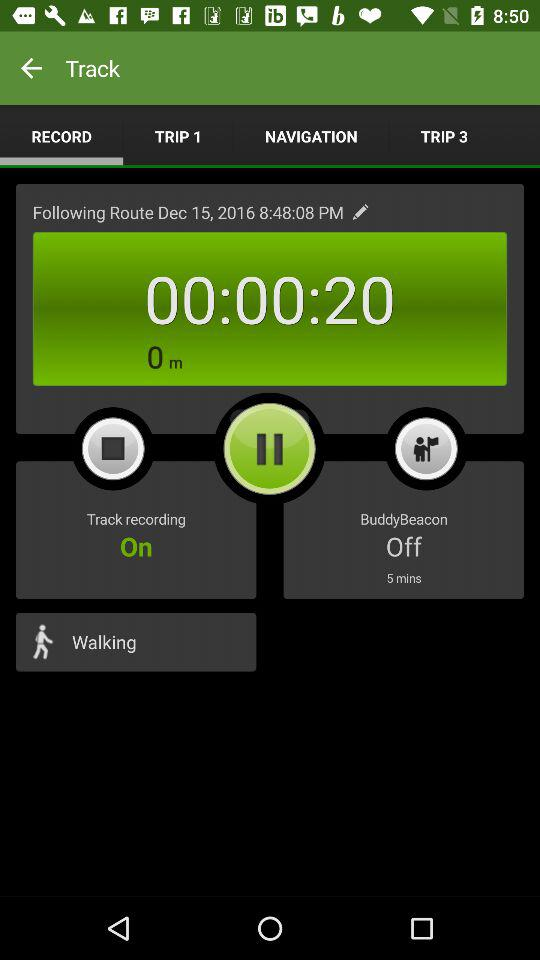How many minutes has the track been going on for?
Answer the question using a single word or phrase. 00:00:20 